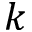<formula> <loc_0><loc_0><loc_500><loc_500>k</formula> 